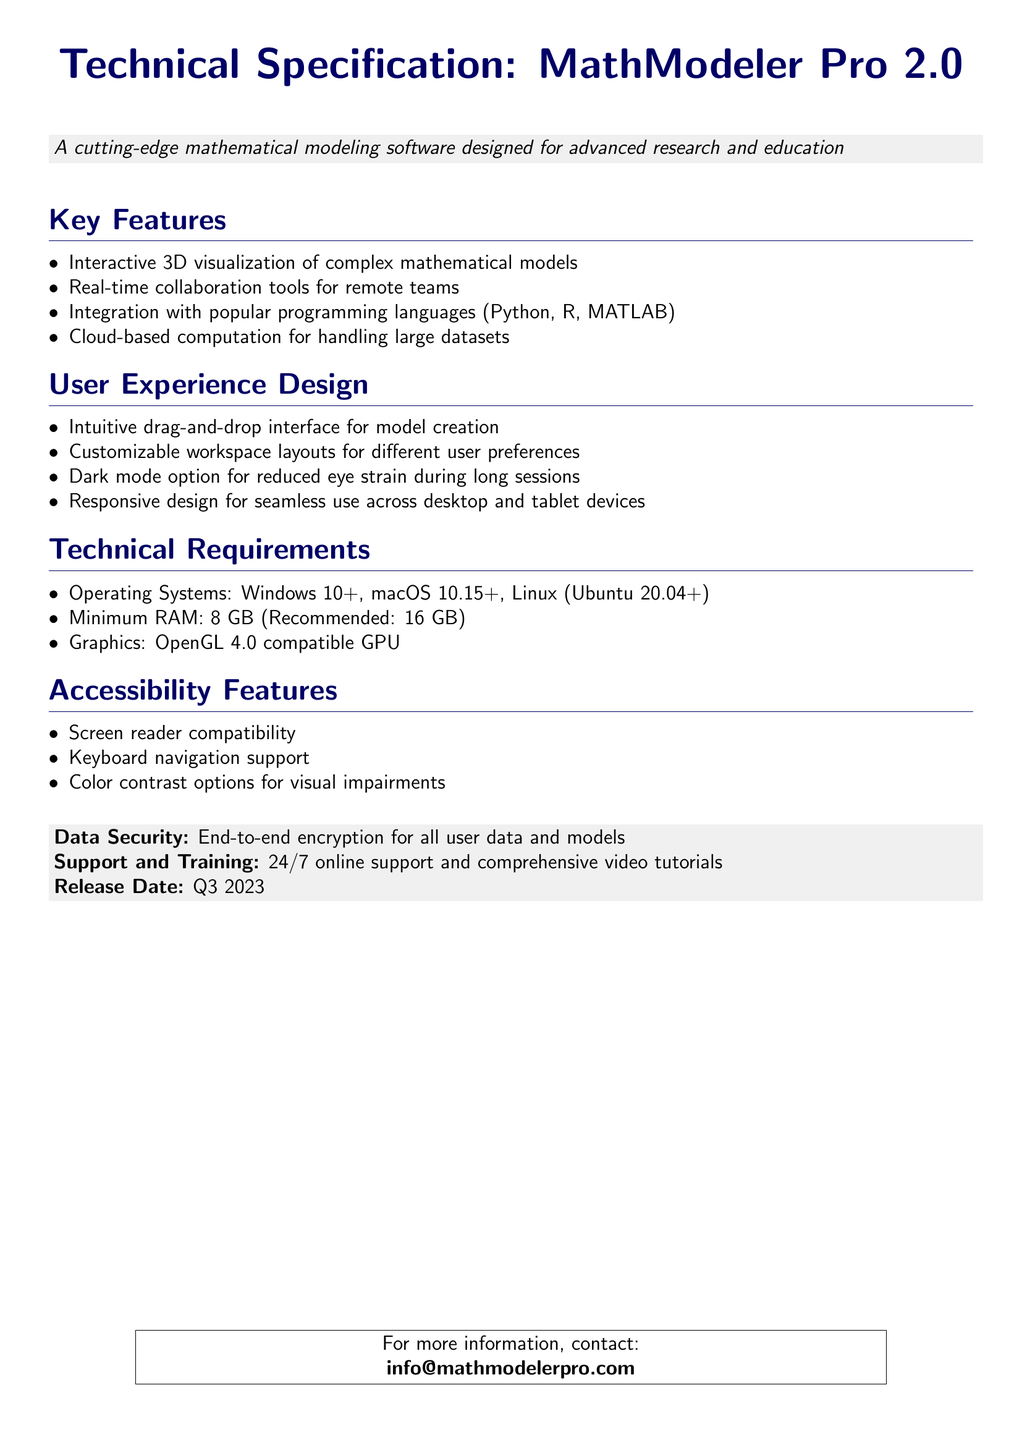What is the title of the document? The title of the document is presented prominently at the top and indicates the subject of the document.
Answer: Technical Specification: MathModeler Pro 2.0 What are the recommended RAM requirements? The document specifies minimum and recommended RAM requirements for optimal software performance.
Answer: 16 GB What operating systems are compatible with MathModeler Pro 2.0? The document lists the operating systems that support the software under Technical Requirements.
Answer: Windows 10+, macOS 10.15+, Linux (Ubuntu 20.04+) What is one of the key features of the software? The document outlines several features under the Key Features section that highlight the software's capabilities.
Answer: Interactive 3D visualization What accessibility feature is mentioned for visual impairments? The document details specific features designed to enhance access for users with disabilities in the Accessibility Features section.
Answer: Color contrast options Which programming languages does MathModeler Pro 2.0 integrate with? The integration capabilities are highlighted under the Key Features section, showcasing the software's compatibility with popular languages.
Answer: Python, R, MATLAB What is the release date of MathModeler Pro 2.0? The document specifies the release timing of the software in a highlighted section near the bottom of the content.
Answer: Q3 2023 How does the software support user collaboration? The document lists various collaborative functionalities that enable teamwork under Key Features.
Answer: Real-time collaboration tools What design option is available to reduce eye strain? The User Experience Design section highlights a feature intended to enhance user comfort during long usage periods.
Answer: Dark mode option 